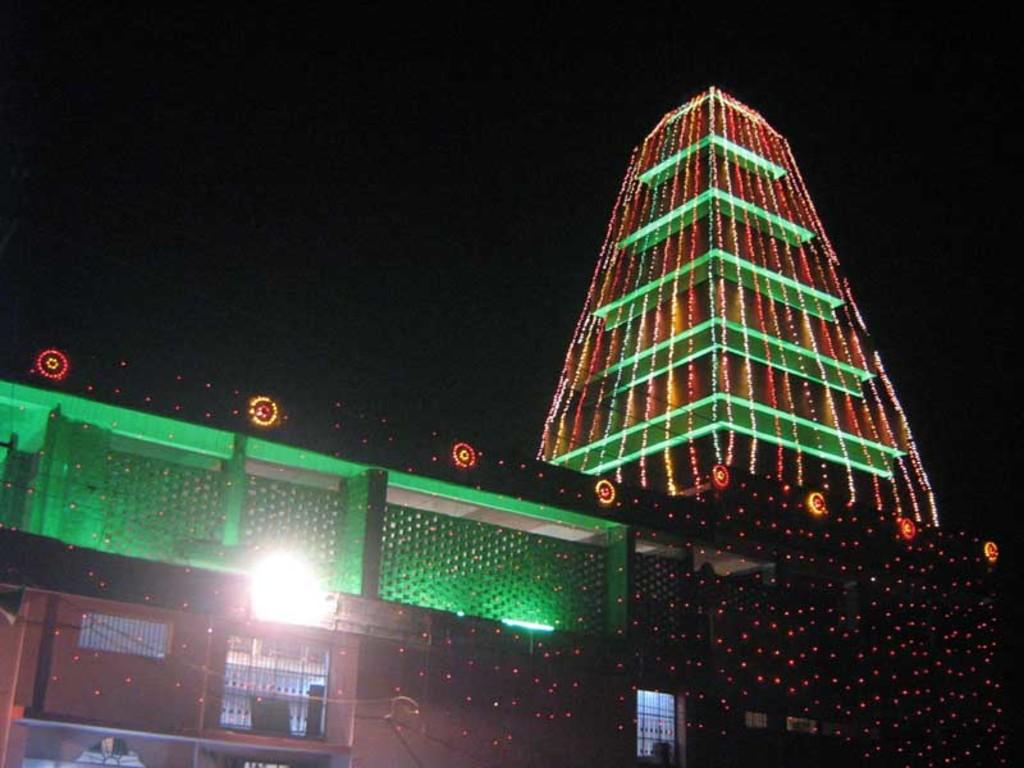What type of structure is visible in the image? There is a building with lights in the image. What architectural feature can be seen on the building? There are iron grilles in the image. How would you describe the lighting conditions in the image? The background of the image is dark. What role does the governor play in the image? There is no governor present in the image, so it is not possible to determine their role. 